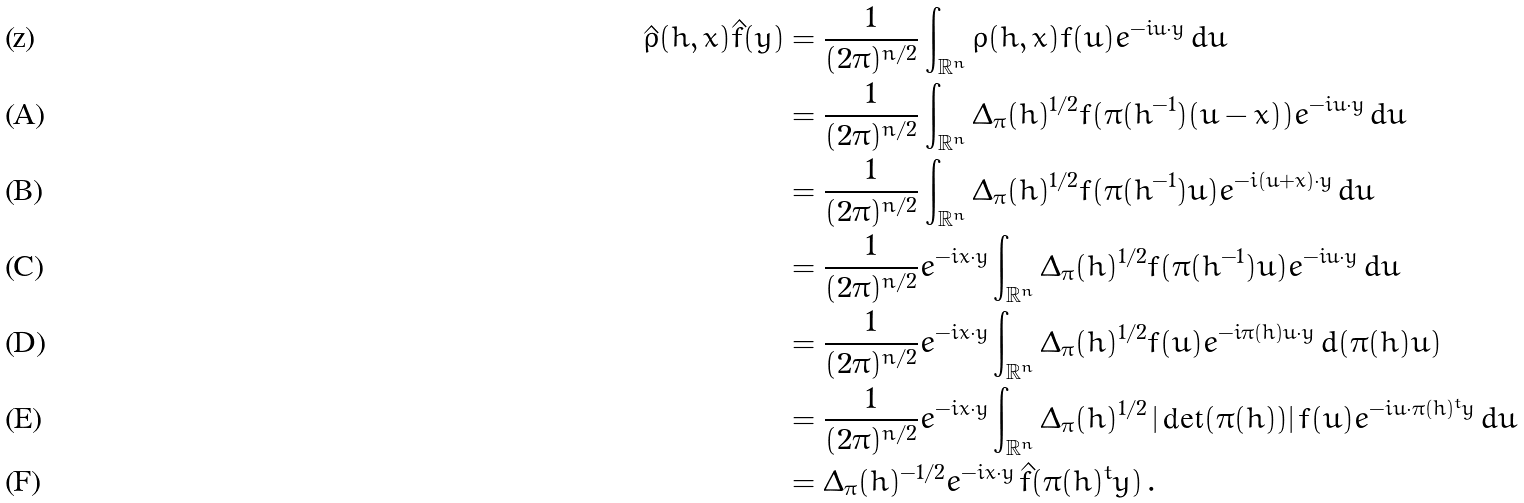<formula> <loc_0><loc_0><loc_500><loc_500>\hat { \rho } ( h , x ) \hat { f } ( y ) & = \frac { 1 } { ( 2 \pi ) ^ { n / 2 } } \int _ { \mathbb { R } ^ { n } } \rho ( h , x ) f ( u ) e ^ { - i u \cdot y } \, d u \\ & = \frac { 1 } { ( 2 \pi ) ^ { n / 2 } } \int _ { \mathbb { R } ^ { n } } \Delta _ { \pi } ( h ) ^ { 1 / 2 } f ( \pi ( h ^ { - 1 } ) ( u - x ) ) e ^ { - i u \cdot y } \, d u \\ & = \frac { 1 } { ( 2 \pi ) ^ { n / 2 } } \int _ { \mathbb { R } ^ { n } } \Delta _ { \pi } ( h ) ^ { 1 / 2 } f ( \pi ( h ^ { - 1 } ) u ) e ^ { - i ( u + x ) \cdot y } \, d u \\ & = \frac { 1 } { ( 2 \pi ) ^ { n / 2 } } e ^ { - i x \cdot y } \int _ { \mathbb { R } ^ { n } } \Delta _ { \pi } ( h ) ^ { 1 / 2 } f ( \pi ( h ^ { - 1 } ) u ) e ^ { - i u \cdot y } \, d u \\ & = \frac { 1 } { ( 2 \pi ) ^ { n / 2 } } e ^ { - i x \cdot y } \int _ { \mathbb { R } ^ { n } } \Delta _ { \pi } ( h ) ^ { 1 / 2 } f ( u ) e ^ { - i \pi ( h ) u \cdot y } \, d ( \pi ( h ) u ) \\ & = \frac { 1 } { ( 2 \pi ) ^ { n / 2 } } e ^ { - i x \cdot y } \int _ { \mathbb { R } ^ { n } } \Delta _ { \pi } ( h ) ^ { 1 / 2 } \, | \det ( \pi ( h ) ) | \, f ( u ) e ^ { - i u \cdot \pi ( h ) ^ { t } y } \, d u \\ & = \Delta _ { \pi } ( h ) ^ { - 1 / 2 } e ^ { - i x \cdot y } \, \hat { f } ( \pi ( h ) ^ { t } y ) \, .</formula> 